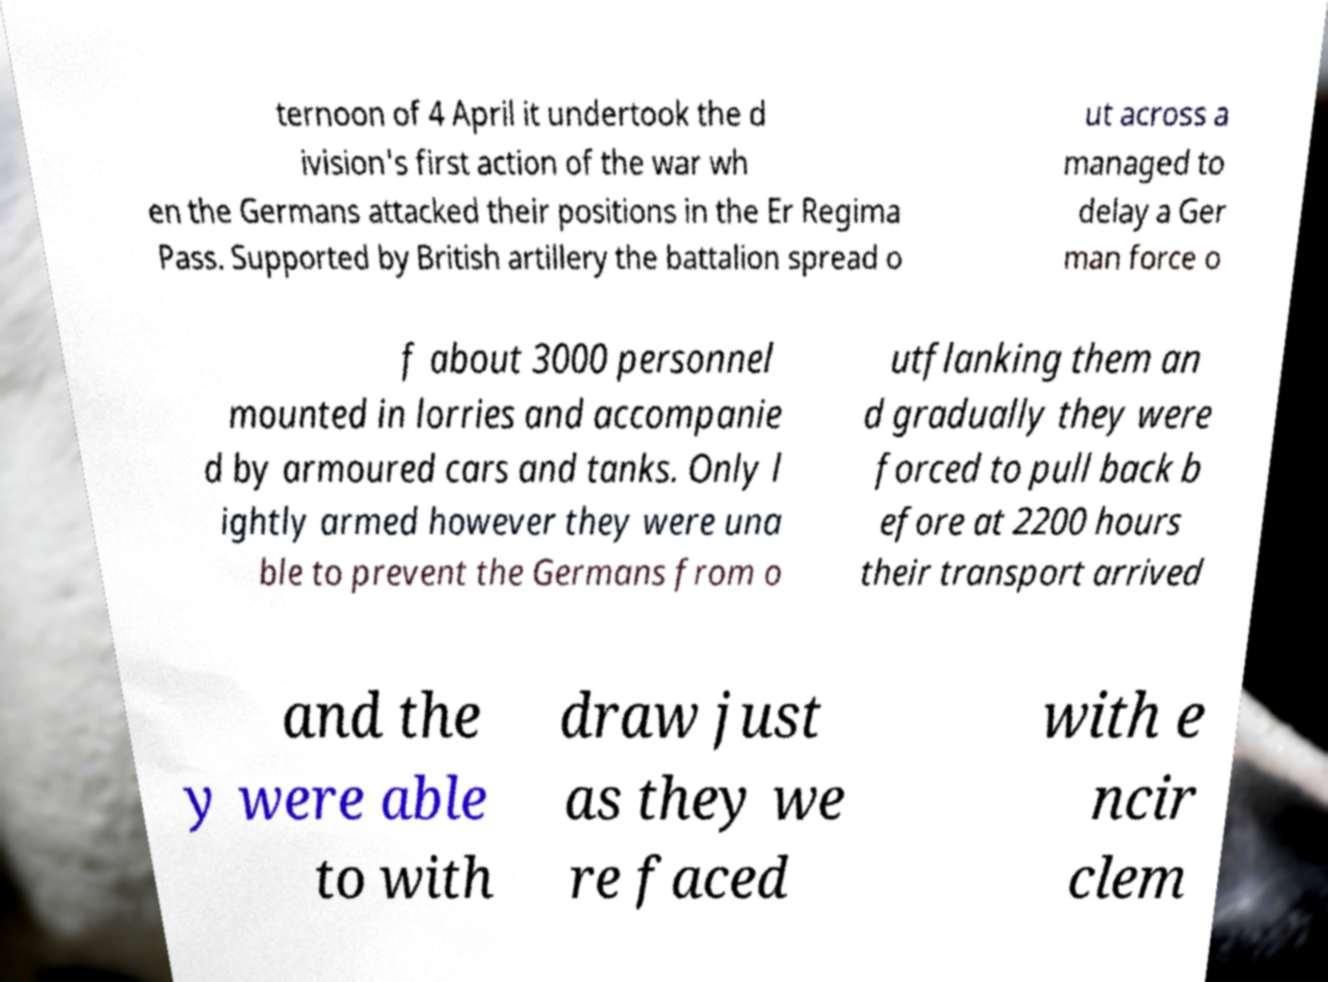There's text embedded in this image that I need extracted. Can you transcribe it verbatim? ternoon of 4 April it undertook the d ivision's first action of the war wh en the Germans attacked their positions in the Er Regima Pass. Supported by British artillery the battalion spread o ut across a managed to delay a Ger man force o f about 3000 personnel mounted in lorries and accompanie d by armoured cars and tanks. Only l ightly armed however they were una ble to prevent the Germans from o utflanking them an d gradually they were forced to pull back b efore at 2200 hours their transport arrived and the y were able to with draw just as they we re faced with e ncir clem 